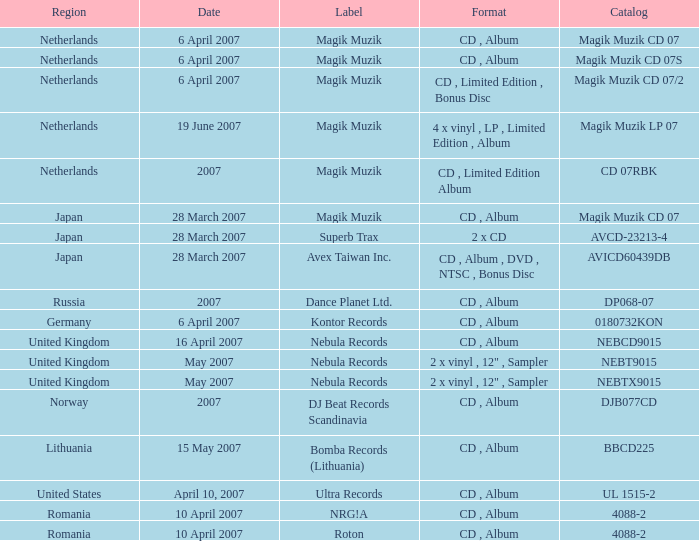What was the label that launched magik muzik cd 07 on march 28, 2007? Magik Muzik. 